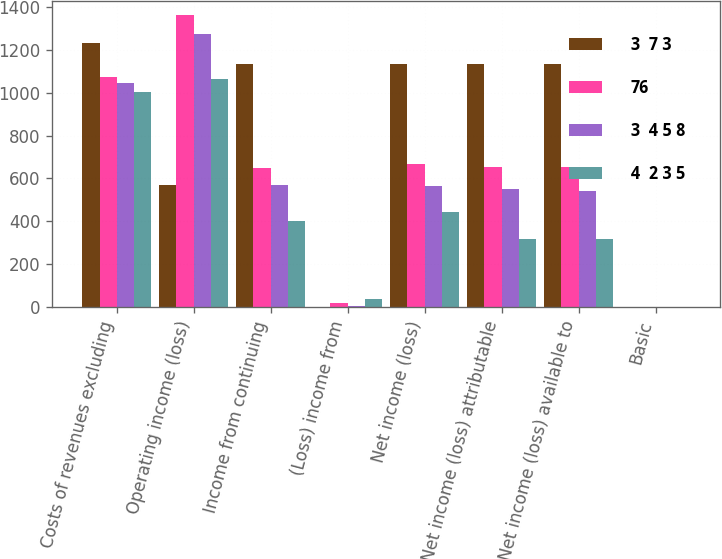Convert chart to OTSL. <chart><loc_0><loc_0><loc_500><loc_500><stacked_bar_chart><ecel><fcel>Costs of revenues excluding<fcel>Operating income (loss)<fcel>Income from continuing<fcel>(Loss) income from<fcel>Net income (loss)<fcel>Net income (loss) attributable<fcel>Net income (loss) available to<fcel>Basic<nl><fcel>3  7 3<fcel>1233<fcel>570<fcel>1134<fcel>1<fcel>1133<fcel>1132<fcel>1132<fcel>2.82<nl><fcel>76<fcel>1073<fcel>1360<fcel>647<fcel>22<fcel>669<fcel>653<fcel>652<fcel>1.48<nl><fcel>3  4 5 8<fcel>1044<fcel>1274<fcel>570<fcel>6<fcel>564<fcel>549<fcel>541<fcel>1.29<nl><fcel>4  2 3 5<fcel>1002<fcel>1064<fcel>404<fcel>40<fcel>444<fcel>317<fcel>317<fcel>0.86<nl></chart> 